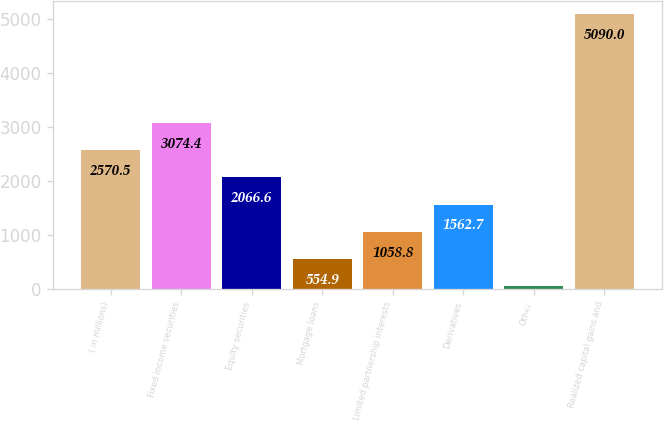Convert chart. <chart><loc_0><loc_0><loc_500><loc_500><bar_chart><fcel>( in millions)<fcel>Fixed income securities<fcel>Equity securities<fcel>Mortgage loans<fcel>Limited partnership interests<fcel>Derivatives<fcel>Other<fcel>Realized capital gains and<nl><fcel>2570.5<fcel>3074.4<fcel>2066.6<fcel>554.9<fcel>1058.8<fcel>1562.7<fcel>51<fcel>5090<nl></chart> 